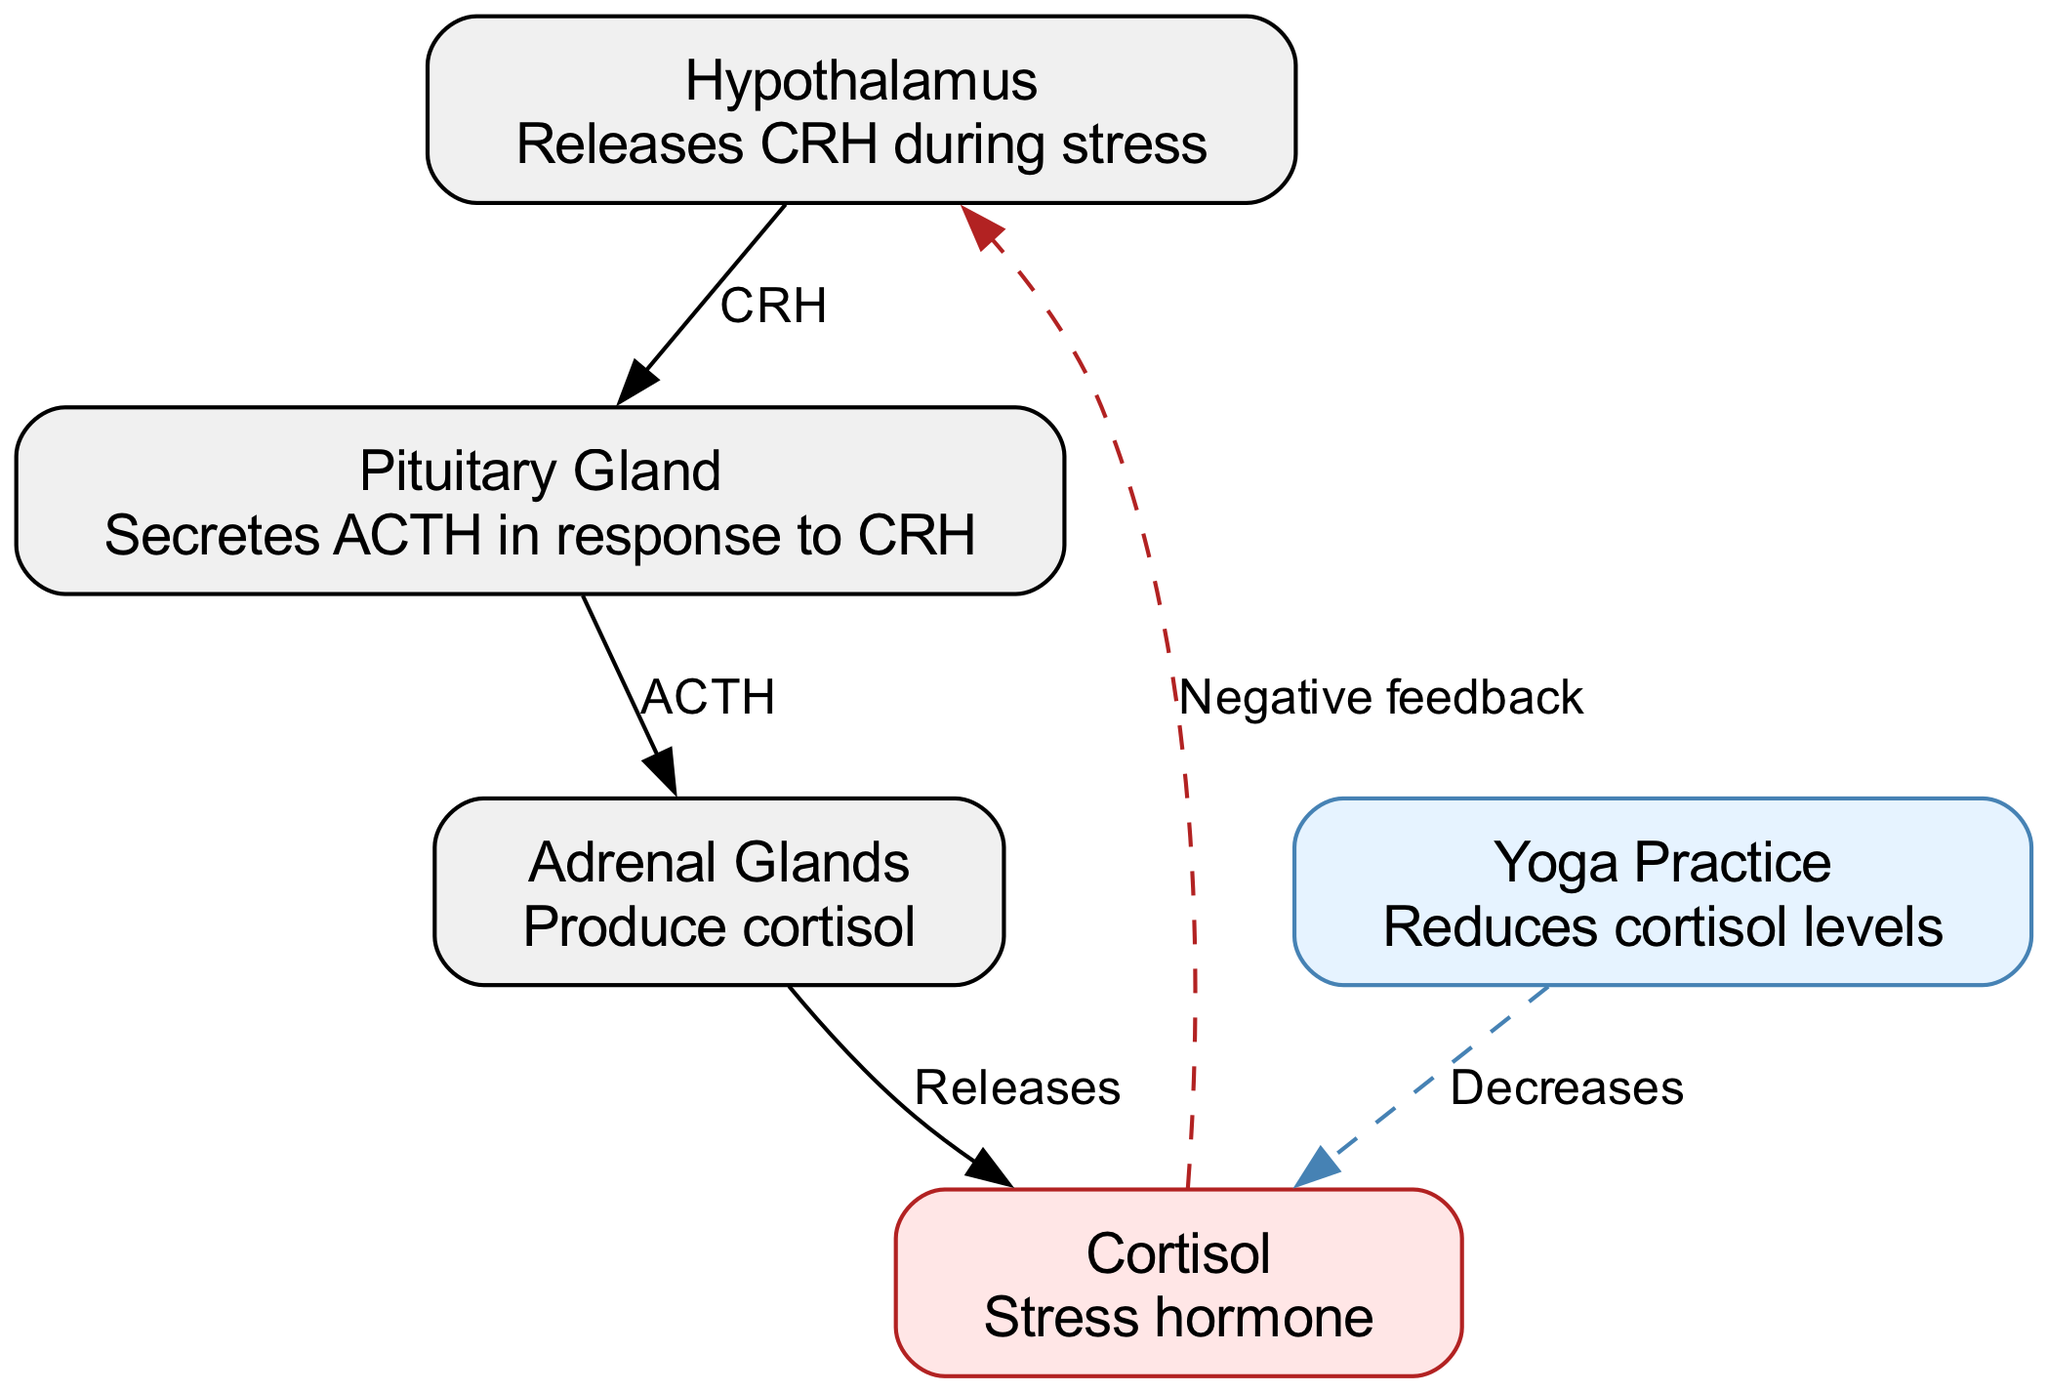what hormone is released by the hypothalamus during stress? The diagram indicates that the hypothalamus releases CRH (Corticotropin-Releasing Hormone) during stress, as stated in the description of the hypothalamus node.
Answer: CRH how many nodes are present in the diagram? The diagram lists five nodes: hypothalamus, pituitary gland, adrenal glands, cortisol, and yoga practice. Counting these gives a total of five nodes.
Answer: 5 what is the relationship between the pituitary gland and adrenal glands? The edge between the pituitary gland and adrenal glands indicates that the pituitary gland secretes ACTH (Adrenocorticotropic Hormone) in response to CRH. This can be understood from the directed edge labeled "ACTH".
Answer: ACTH what effect does yoga practice have on cortisol levels? The diagram shows an edge from the yoga practice node to the cortisol node, labeled "Decreases", indicating that yoga practice reduces cortisol levels. Thus, the relationship clearly states the impact of yoga practice.
Answer: Decreases what feedback mechanism is illustrated from cortisol to hypothalamus? The diagram specifies a directed edge from cortisol to the hypothalamus labeled "Negative feedback". This indicates that cortisol, once released, has a feedback effect on the hypothalamus to regulate further hormone release.
Answer: Negative feedback which glands are responsible for producing cortisol? The diagram notes that the adrenal glands are responsible for producing cortisol, as indicated in the description of the adrenal glands node. This can be verified by following the directed edge from the adrenal node to the cortisol node.
Answer: Adrenal Glands which part of the diagram indicates the role of stress hormone? The cortisol node in the diagram is described as the "Stress hormone". This highlights its function in the stress response, making it central to understanding the neuroanatomy of stress.
Answer: Cortisol which node shows a potential alternative method for stress reduction? The yoga node illustrates an alternative method for stress reduction, as depicted by the edge connecting yoga practice to cortisol and labeled "Decreases". This implies that yoga can help manage stress.
Answer: Yoga Practice how do the adrenal glands influence cortisol dynamics? The adrenal glands produce cortisol, which is indicated by the direct edge from the adrenal node to the cortisol node. This demonstrates a direct influence on cortisol dynamics by producing it in response to ACTH.
Answer: Produce cortisol 